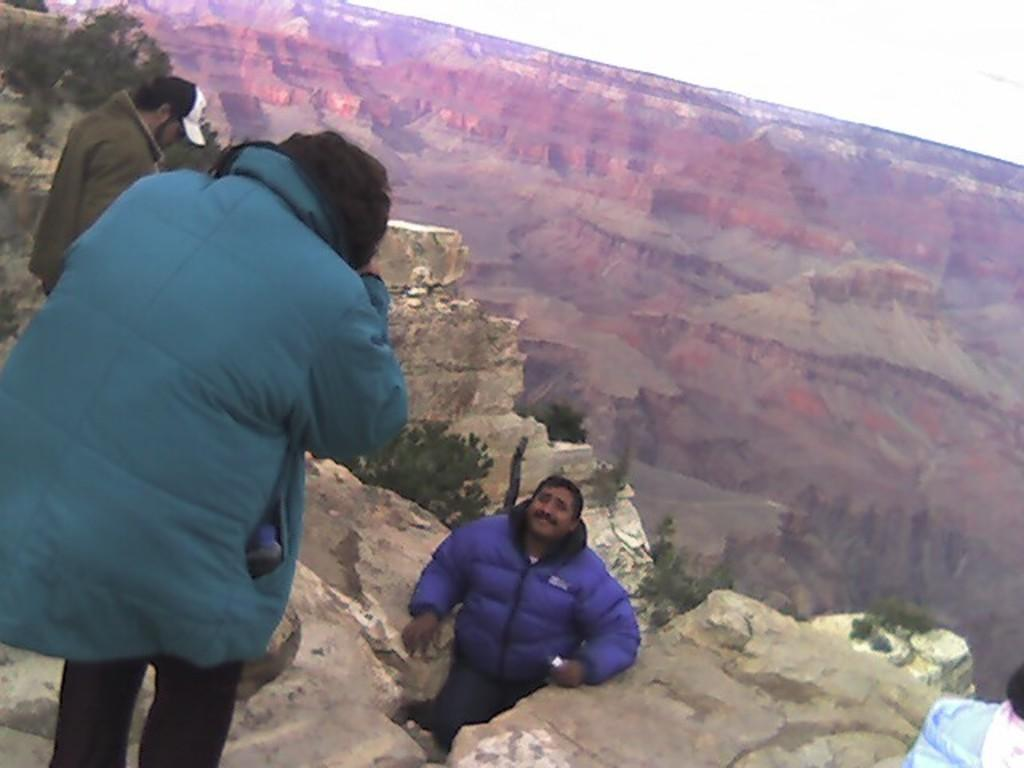Who or what can be seen in the image? There are people in the image. What type of natural features are present in the image? There are rocks, mountains, and trees in the image. What can be seen in the background of the image? The sky is visible in the background of the image. What type of goose is sitting on the hammer in the image? There is no goose or hammer present in the image. How is the popcorn being used in the image? There is no popcorn present in the image. 